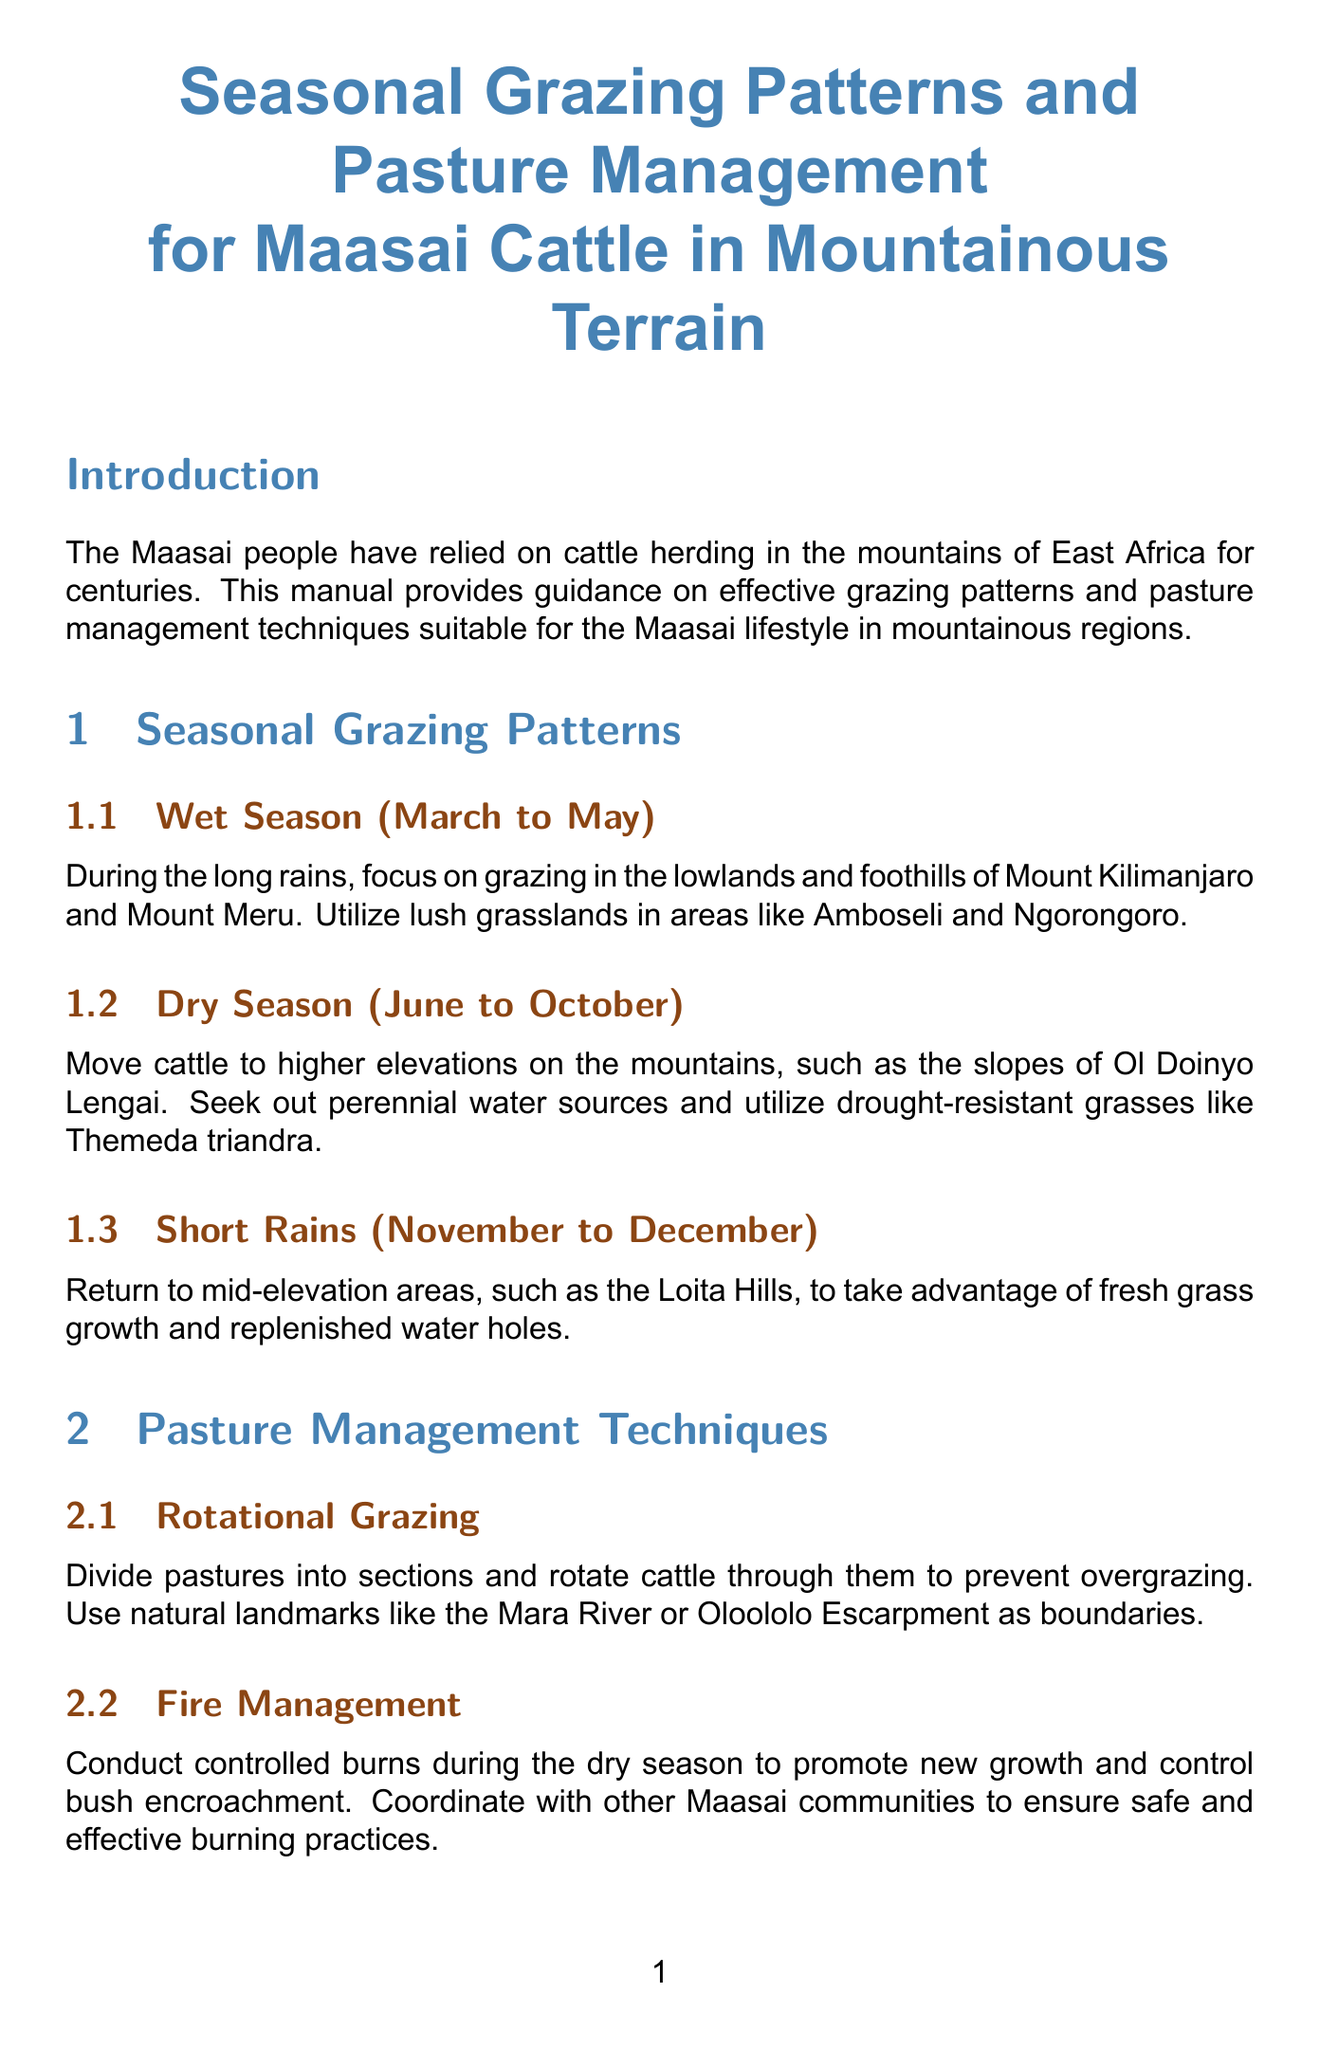What is the focus during the wet season? The wet season emphasizes grazing in specific areas like lowlands and foothills, particularly noted for their lush grasslands.
Answer: lowlands and foothills When is the dry season? The dry season is a specific period that occurs between June and October each year.
Answer: June to October What management technique involves dividing pastures? This technique specifically aims to promote sustainability and prevent overgrazing by rotating cattle through different sections of pastures.
Answer: Rotational Grazing Which indigenous plant is highlighted for preservation? The document mentions native grass species that are especially adapted to local conditions as key forage sources.
Answer: Digitaria macroblephara What is one way to predict weather traditionally? The document provides methods that draw from nature observations, such as checking specific plants or animal behavior.
Answer: flowering of certain plants What is one alternative livelihood suggested? The manual provides ideas for diversifying income sources that can complement cattle herding, which helps with economic stability.
Answer: beekeeping Which cattle breed is recommended for drought resistance? This is suggested to improve adaptability to changing environmental conditions while maintaining cultural significance.
Answer: Boran What does the document suggest for wildlife coexistence? This strategy focuses on methods that reduce conflict between livestock and wildlife while ensuring sustainable land use practices.
Answer: traditional fencing methods What is a key aspect of fire management? The document indicates a controlled approach to burning as a way to enhance pasture growth and diminish unwanted vegetation.
Answer: controlled burns 